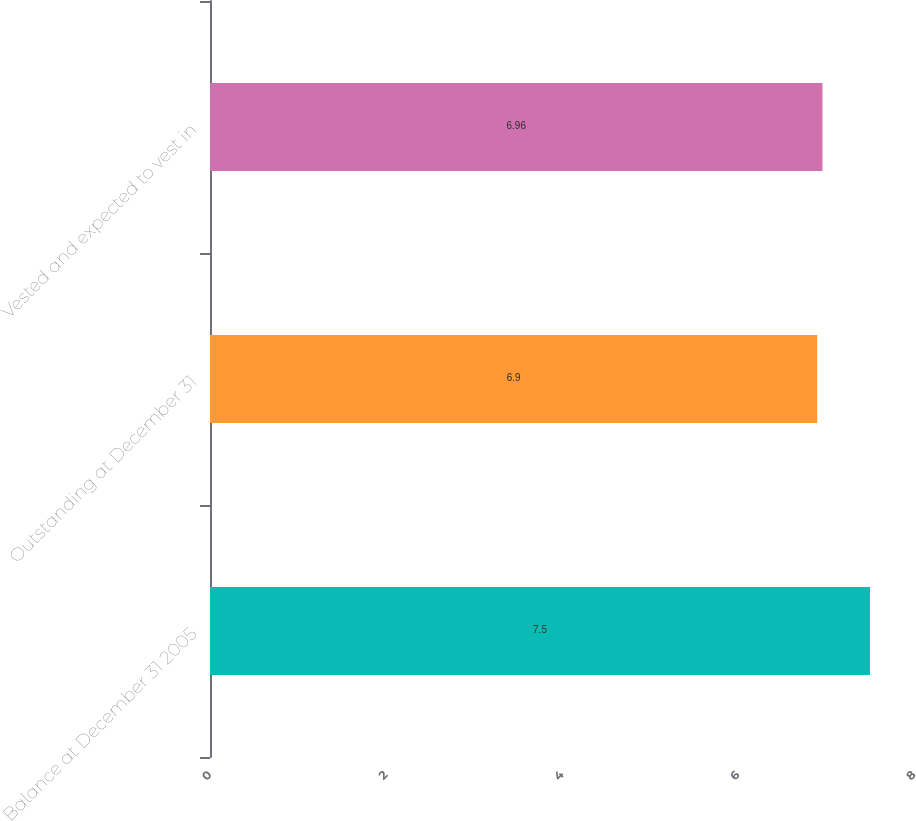<chart> <loc_0><loc_0><loc_500><loc_500><bar_chart><fcel>Balance at December 31 2005<fcel>Outstanding at December 31<fcel>Vested and expected to vest in<nl><fcel>7.5<fcel>6.9<fcel>6.96<nl></chart> 